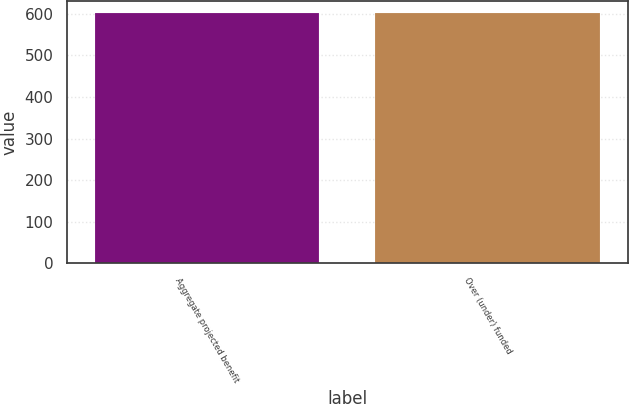Convert chart to OTSL. <chart><loc_0><loc_0><loc_500><loc_500><bar_chart><fcel>Aggregate projected benefit<fcel>Over (under) funded<nl><fcel>601<fcel>601.1<nl></chart> 